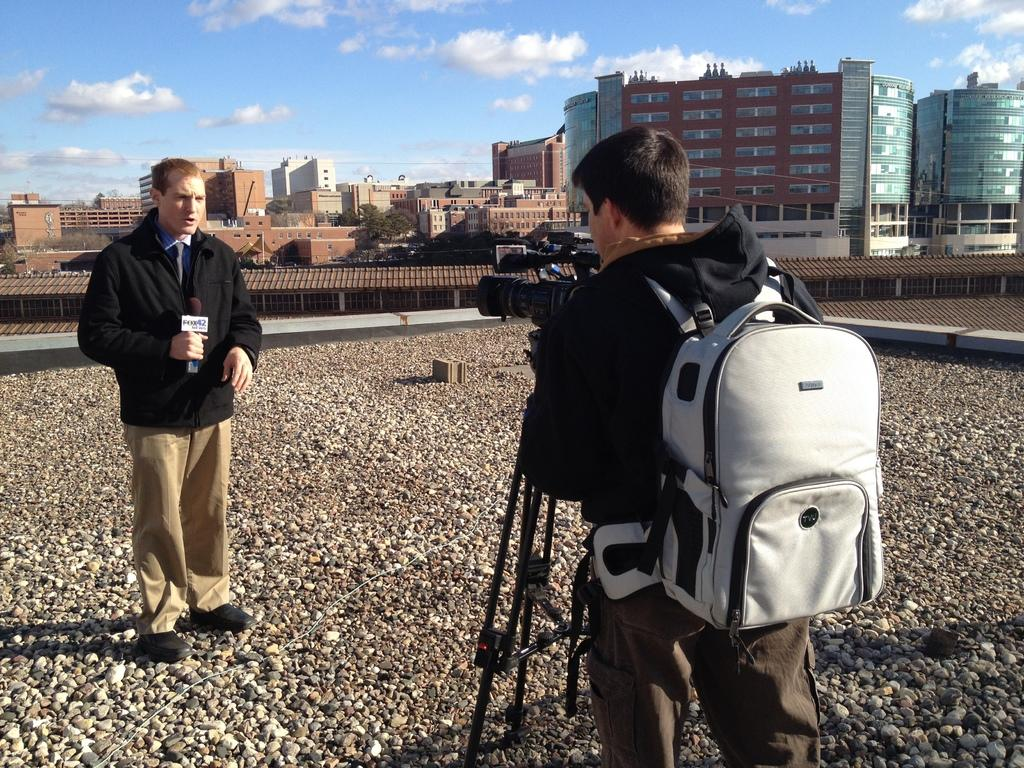What is the guy in the image wearing on his back? There is a guy wearing a backpack in the image. What is the guy with the backpack holding in his hand? The guy with the backpack is holding a camera. Can you describe the other person in the image? There is another guy in the image, and he is catching a microphone. What can be seen in the background of the image? There are many buildings in the background of the image. Can you tell me how many cows are present in the image? There are no cows present in the image. Is the guy with the backpack a spy in the image? There is no information in the image to suggest that the guy with the backpack is a spy. 